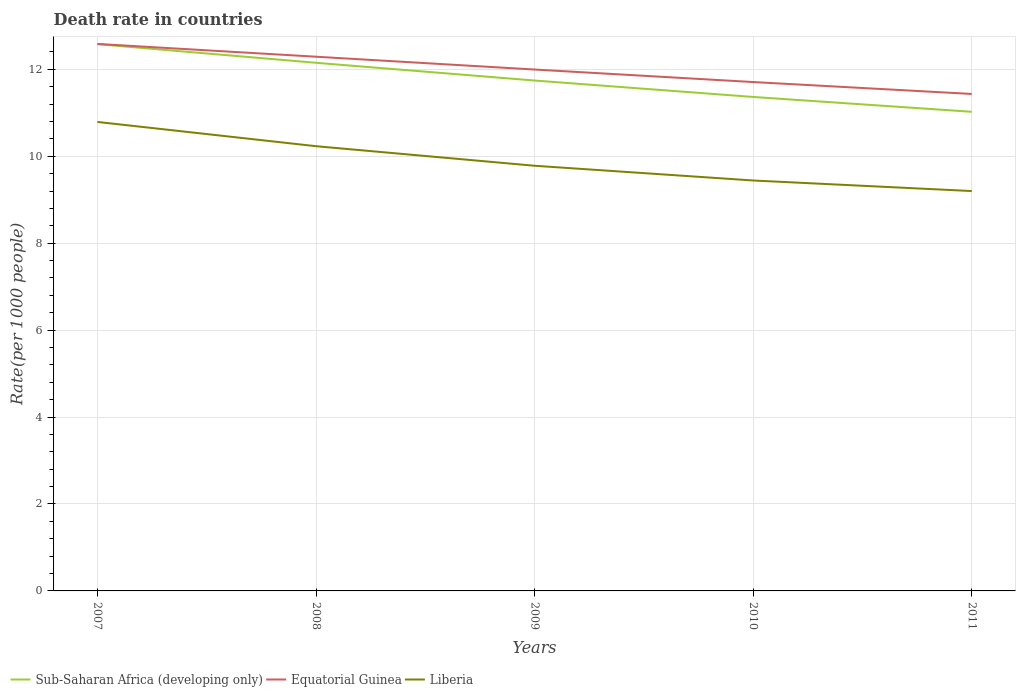Does the line corresponding to Equatorial Guinea intersect with the line corresponding to Liberia?
Ensure brevity in your answer.  No. Across all years, what is the maximum death rate in Sub-Saharan Africa (developing only)?
Your response must be concise. 11.02. What is the total death rate in Liberia in the graph?
Make the answer very short. 0.79. What is the difference between the highest and the second highest death rate in Equatorial Guinea?
Your response must be concise. 1.15. Is the death rate in Sub-Saharan Africa (developing only) strictly greater than the death rate in Equatorial Guinea over the years?
Provide a succinct answer. Yes. How many lines are there?
Provide a succinct answer. 3. How many years are there in the graph?
Ensure brevity in your answer.  5. Are the values on the major ticks of Y-axis written in scientific E-notation?
Offer a terse response. No. Does the graph contain any zero values?
Offer a terse response. No. Does the graph contain grids?
Keep it short and to the point. Yes. How many legend labels are there?
Ensure brevity in your answer.  3. How are the legend labels stacked?
Keep it short and to the point. Horizontal. What is the title of the graph?
Keep it short and to the point. Death rate in countries. What is the label or title of the X-axis?
Provide a short and direct response. Years. What is the label or title of the Y-axis?
Give a very brief answer. Rate(per 1000 people). What is the Rate(per 1000 people) in Sub-Saharan Africa (developing only) in 2007?
Your response must be concise. 12.58. What is the Rate(per 1000 people) of Equatorial Guinea in 2007?
Keep it short and to the point. 12.59. What is the Rate(per 1000 people) of Liberia in 2007?
Provide a succinct answer. 10.79. What is the Rate(per 1000 people) in Sub-Saharan Africa (developing only) in 2008?
Make the answer very short. 12.15. What is the Rate(per 1000 people) in Equatorial Guinea in 2008?
Your answer should be compact. 12.29. What is the Rate(per 1000 people) of Liberia in 2008?
Offer a terse response. 10.23. What is the Rate(per 1000 people) in Sub-Saharan Africa (developing only) in 2009?
Keep it short and to the point. 11.74. What is the Rate(per 1000 people) in Equatorial Guinea in 2009?
Your response must be concise. 12. What is the Rate(per 1000 people) of Liberia in 2009?
Offer a very short reply. 9.78. What is the Rate(per 1000 people) in Sub-Saharan Africa (developing only) in 2010?
Offer a very short reply. 11.36. What is the Rate(per 1000 people) in Equatorial Guinea in 2010?
Your answer should be compact. 11.71. What is the Rate(per 1000 people) in Liberia in 2010?
Give a very brief answer. 9.44. What is the Rate(per 1000 people) of Sub-Saharan Africa (developing only) in 2011?
Keep it short and to the point. 11.02. What is the Rate(per 1000 people) of Equatorial Guinea in 2011?
Offer a terse response. 11.43. Across all years, what is the maximum Rate(per 1000 people) in Sub-Saharan Africa (developing only)?
Keep it short and to the point. 12.58. Across all years, what is the maximum Rate(per 1000 people) in Equatorial Guinea?
Your answer should be compact. 12.59. Across all years, what is the maximum Rate(per 1000 people) in Liberia?
Provide a succinct answer. 10.79. Across all years, what is the minimum Rate(per 1000 people) of Sub-Saharan Africa (developing only)?
Your response must be concise. 11.02. Across all years, what is the minimum Rate(per 1000 people) of Equatorial Guinea?
Your answer should be compact. 11.43. What is the total Rate(per 1000 people) in Sub-Saharan Africa (developing only) in the graph?
Make the answer very short. 58.86. What is the total Rate(per 1000 people) of Equatorial Guinea in the graph?
Give a very brief answer. 60.01. What is the total Rate(per 1000 people) of Liberia in the graph?
Ensure brevity in your answer.  49.45. What is the difference between the Rate(per 1000 people) of Sub-Saharan Africa (developing only) in 2007 and that in 2008?
Ensure brevity in your answer.  0.43. What is the difference between the Rate(per 1000 people) of Equatorial Guinea in 2007 and that in 2008?
Your response must be concise. 0.29. What is the difference between the Rate(per 1000 people) of Liberia in 2007 and that in 2008?
Give a very brief answer. 0.56. What is the difference between the Rate(per 1000 people) in Sub-Saharan Africa (developing only) in 2007 and that in 2009?
Keep it short and to the point. 0.84. What is the difference between the Rate(per 1000 people) in Equatorial Guinea in 2007 and that in 2009?
Ensure brevity in your answer.  0.59. What is the difference between the Rate(per 1000 people) in Liberia in 2007 and that in 2009?
Your answer should be compact. 1.01. What is the difference between the Rate(per 1000 people) in Sub-Saharan Africa (developing only) in 2007 and that in 2010?
Your answer should be very brief. 1.21. What is the difference between the Rate(per 1000 people) in Equatorial Guinea in 2007 and that in 2010?
Make the answer very short. 0.88. What is the difference between the Rate(per 1000 people) in Liberia in 2007 and that in 2010?
Give a very brief answer. 1.35. What is the difference between the Rate(per 1000 people) in Sub-Saharan Africa (developing only) in 2007 and that in 2011?
Keep it short and to the point. 1.56. What is the difference between the Rate(per 1000 people) of Equatorial Guinea in 2007 and that in 2011?
Give a very brief answer. 1.15. What is the difference between the Rate(per 1000 people) in Liberia in 2007 and that in 2011?
Provide a short and direct response. 1.59. What is the difference between the Rate(per 1000 people) in Sub-Saharan Africa (developing only) in 2008 and that in 2009?
Your answer should be compact. 0.41. What is the difference between the Rate(per 1000 people) of Equatorial Guinea in 2008 and that in 2009?
Your answer should be compact. 0.29. What is the difference between the Rate(per 1000 people) in Liberia in 2008 and that in 2009?
Your answer should be very brief. 0.45. What is the difference between the Rate(per 1000 people) of Sub-Saharan Africa (developing only) in 2008 and that in 2010?
Provide a succinct answer. 0.79. What is the difference between the Rate(per 1000 people) in Equatorial Guinea in 2008 and that in 2010?
Your response must be concise. 0.58. What is the difference between the Rate(per 1000 people) in Liberia in 2008 and that in 2010?
Provide a succinct answer. 0.79. What is the difference between the Rate(per 1000 people) of Sub-Saharan Africa (developing only) in 2008 and that in 2011?
Provide a succinct answer. 1.13. What is the difference between the Rate(per 1000 people) in Equatorial Guinea in 2008 and that in 2011?
Ensure brevity in your answer.  0.86. What is the difference between the Rate(per 1000 people) of Liberia in 2008 and that in 2011?
Your response must be concise. 1.03. What is the difference between the Rate(per 1000 people) in Sub-Saharan Africa (developing only) in 2009 and that in 2010?
Provide a short and direct response. 0.38. What is the difference between the Rate(per 1000 people) in Equatorial Guinea in 2009 and that in 2010?
Offer a terse response. 0.29. What is the difference between the Rate(per 1000 people) of Liberia in 2009 and that in 2010?
Your answer should be very brief. 0.34. What is the difference between the Rate(per 1000 people) of Sub-Saharan Africa (developing only) in 2009 and that in 2011?
Offer a very short reply. 0.72. What is the difference between the Rate(per 1000 people) of Equatorial Guinea in 2009 and that in 2011?
Provide a succinct answer. 0.56. What is the difference between the Rate(per 1000 people) in Liberia in 2009 and that in 2011?
Make the answer very short. 0.58. What is the difference between the Rate(per 1000 people) of Sub-Saharan Africa (developing only) in 2010 and that in 2011?
Offer a very short reply. 0.34. What is the difference between the Rate(per 1000 people) of Equatorial Guinea in 2010 and that in 2011?
Provide a short and direct response. 0.27. What is the difference between the Rate(per 1000 people) of Liberia in 2010 and that in 2011?
Your answer should be compact. 0.24. What is the difference between the Rate(per 1000 people) in Sub-Saharan Africa (developing only) in 2007 and the Rate(per 1000 people) in Equatorial Guinea in 2008?
Offer a very short reply. 0.29. What is the difference between the Rate(per 1000 people) in Sub-Saharan Africa (developing only) in 2007 and the Rate(per 1000 people) in Liberia in 2008?
Offer a terse response. 2.35. What is the difference between the Rate(per 1000 people) of Equatorial Guinea in 2007 and the Rate(per 1000 people) of Liberia in 2008?
Provide a succinct answer. 2.35. What is the difference between the Rate(per 1000 people) in Sub-Saharan Africa (developing only) in 2007 and the Rate(per 1000 people) in Equatorial Guinea in 2009?
Offer a very short reply. 0.58. What is the difference between the Rate(per 1000 people) in Sub-Saharan Africa (developing only) in 2007 and the Rate(per 1000 people) in Liberia in 2009?
Your answer should be very brief. 2.8. What is the difference between the Rate(per 1000 people) of Equatorial Guinea in 2007 and the Rate(per 1000 people) of Liberia in 2009?
Keep it short and to the point. 2.8. What is the difference between the Rate(per 1000 people) in Sub-Saharan Africa (developing only) in 2007 and the Rate(per 1000 people) in Equatorial Guinea in 2010?
Make the answer very short. 0.87. What is the difference between the Rate(per 1000 people) in Sub-Saharan Africa (developing only) in 2007 and the Rate(per 1000 people) in Liberia in 2010?
Ensure brevity in your answer.  3.14. What is the difference between the Rate(per 1000 people) of Equatorial Guinea in 2007 and the Rate(per 1000 people) of Liberia in 2010?
Offer a very short reply. 3.14. What is the difference between the Rate(per 1000 people) of Sub-Saharan Africa (developing only) in 2007 and the Rate(per 1000 people) of Equatorial Guinea in 2011?
Your response must be concise. 1.15. What is the difference between the Rate(per 1000 people) in Sub-Saharan Africa (developing only) in 2007 and the Rate(per 1000 people) in Liberia in 2011?
Provide a succinct answer. 3.38. What is the difference between the Rate(per 1000 people) in Equatorial Guinea in 2007 and the Rate(per 1000 people) in Liberia in 2011?
Your answer should be compact. 3.38. What is the difference between the Rate(per 1000 people) in Sub-Saharan Africa (developing only) in 2008 and the Rate(per 1000 people) in Equatorial Guinea in 2009?
Provide a short and direct response. 0.16. What is the difference between the Rate(per 1000 people) of Sub-Saharan Africa (developing only) in 2008 and the Rate(per 1000 people) of Liberia in 2009?
Your answer should be very brief. 2.37. What is the difference between the Rate(per 1000 people) in Equatorial Guinea in 2008 and the Rate(per 1000 people) in Liberia in 2009?
Provide a succinct answer. 2.51. What is the difference between the Rate(per 1000 people) of Sub-Saharan Africa (developing only) in 2008 and the Rate(per 1000 people) of Equatorial Guinea in 2010?
Provide a succinct answer. 0.44. What is the difference between the Rate(per 1000 people) of Sub-Saharan Africa (developing only) in 2008 and the Rate(per 1000 people) of Liberia in 2010?
Your answer should be very brief. 2.71. What is the difference between the Rate(per 1000 people) of Equatorial Guinea in 2008 and the Rate(per 1000 people) of Liberia in 2010?
Your answer should be very brief. 2.85. What is the difference between the Rate(per 1000 people) of Sub-Saharan Africa (developing only) in 2008 and the Rate(per 1000 people) of Equatorial Guinea in 2011?
Ensure brevity in your answer.  0.72. What is the difference between the Rate(per 1000 people) in Sub-Saharan Africa (developing only) in 2008 and the Rate(per 1000 people) in Liberia in 2011?
Provide a short and direct response. 2.95. What is the difference between the Rate(per 1000 people) in Equatorial Guinea in 2008 and the Rate(per 1000 people) in Liberia in 2011?
Provide a short and direct response. 3.09. What is the difference between the Rate(per 1000 people) of Sub-Saharan Africa (developing only) in 2009 and the Rate(per 1000 people) of Equatorial Guinea in 2010?
Your response must be concise. 0.03. What is the difference between the Rate(per 1000 people) in Sub-Saharan Africa (developing only) in 2009 and the Rate(per 1000 people) in Liberia in 2010?
Provide a succinct answer. 2.3. What is the difference between the Rate(per 1000 people) of Equatorial Guinea in 2009 and the Rate(per 1000 people) of Liberia in 2010?
Offer a very short reply. 2.55. What is the difference between the Rate(per 1000 people) in Sub-Saharan Africa (developing only) in 2009 and the Rate(per 1000 people) in Equatorial Guinea in 2011?
Your response must be concise. 0.31. What is the difference between the Rate(per 1000 people) in Sub-Saharan Africa (developing only) in 2009 and the Rate(per 1000 people) in Liberia in 2011?
Your response must be concise. 2.54. What is the difference between the Rate(per 1000 people) of Equatorial Guinea in 2009 and the Rate(per 1000 people) of Liberia in 2011?
Offer a very short reply. 2.8. What is the difference between the Rate(per 1000 people) of Sub-Saharan Africa (developing only) in 2010 and the Rate(per 1000 people) of Equatorial Guinea in 2011?
Provide a short and direct response. -0.07. What is the difference between the Rate(per 1000 people) of Sub-Saharan Africa (developing only) in 2010 and the Rate(per 1000 people) of Liberia in 2011?
Ensure brevity in your answer.  2.17. What is the difference between the Rate(per 1000 people) in Equatorial Guinea in 2010 and the Rate(per 1000 people) in Liberia in 2011?
Your response must be concise. 2.51. What is the average Rate(per 1000 people) in Sub-Saharan Africa (developing only) per year?
Your response must be concise. 11.77. What is the average Rate(per 1000 people) in Equatorial Guinea per year?
Your answer should be compact. 12. What is the average Rate(per 1000 people) of Liberia per year?
Your answer should be very brief. 9.89. In the year 2007, what is the difference between the Rate(per 1000 people) in Sub-Saharan Africa (developing only) and Rate(per 1000 people) in Equatorial Guinea?
Provide a short and direct response. -0.01. In the year 2007, what is the difference between the Rate(per 1000 people) of Sub-Saharan Africa (developing only) and Rate(per 1000 people) of Liberia?
Provide a short and direct response. 1.79. In the year 2007, what is the difference between the Rate(per 1000 people) in Equatorial Guinea and Rate(per 1000 people) in Liberia?
Make the answer very short. 1.79. In the year 2008, what is the difference between the Rate(per 1000 people) in Sub-Saharan Africa (developing only) and Rate(per 1000 people) in Equatorial Guinea?
Keep it short and to the point. -0.14. In the year 2008, what is the difference between the Rate(per 1000 people) in Sub-Saharan Africa (developing only) and Rate(per 1000 people) in Liberia?
Provide a succinct answer. 1.92. In the year 2008, what is the difference between the Rate(per 1000 people) in Equatorial Guinea and Rate(per 1000 people) in Liberia?
Provide a short and direct response. 2.06. In the year 2009, what is the difference between the Rate(per 1000 people) in Sub-Saharan Africa (developing only) and Rate(per 1000 people) in Equatorial Guinea?
Give a very brief answer. -0.25. In the year 2009, what is the difference between the Rate(per 1000 people) in Sub-Saharan Africa (developing only) and Rate(per 1000 people) in Liberia?
Your answer should be compact. 1.96. In the year 2009, what is the difference between the Rate(per 1000 people) in Equatorial Guinea and Rate(per 1000 people) in Liberia?
Give a very brief answer. 2.21. In the year 2010, what is the difference between the Rate(per 1000 people) in Sub-Saharan Africa (developing only) and Rate(per 1000 people) in Equatorial Guinea?
Keep it short and to the point. -0.34. In the year 2010, what is the difference between the Rate(per 1000 people) of Sub-Saharan Africa (developing only) and Rate(per 1000 people) of Liberia?
Keep it short and to the point. 1.92. In the year 2010, what is the difference between the Rate(per 1000 people) in Equatorial Guinea and Rate(per 1000 people) in Liberia?
Keep it short and to the point. 2.27. In the year 2011, what is the difference between the Rate(per 1000 people) of Sub-Saharan Africa (developing only) and Rate(per 1000 people) of Equatorial Guinea?
Keep it short and to the point. -0.41. In the year 2011, what is the difference between the Rate(per 1000 people) of Sub-Saharan Africa (developing only) and Rate(per 1000 people) of Liberia?
Ensure brevity in your answer.  1.82. In the year 2011, what is the difference between the Rate(per 1000 people) in Equatorial Guinea and Rate(per 1000 people) in Liberia?
Ensure brevity in your answer.  2.23. What is the ratio of the Rate(per 1000 people) of Sub-Saharan Africa (developing only) in 2007 to that in 2008?
Your answer should be compact. 1.04. What is the ratio of the Rate(per 1000 people) in Equatorial Guinea in 2007 to that in 2008?
Keep it short and to the point. 1.02. What is the ratio of the Rate(per 1000 people) in Liberia in 2007 to that in 2008?
Your answer should be very brief. 1.05. What is the ratio of the Rate(per 1000 people) of Sub-Saharan Africa (developing only) in 2007 to that in 2009?
Ensure brevity in your answer.  1.07. What is the ratio of the Rate(per 1000 people) in Equatorial Guinea in 2007 to that in 2009?
Provide a succinct answer. 1.05. What is the ratio of the Rate(per 1000 people) of Liberia in 2007 to that in 2009?
Offer a very short reply. 1.1. What is the ratio of the Rate(per 1000 people) of Sub-Saharan Africa (developing only) in 2007 to that in 2010?
Provide a succinct answer. 1.11. What is the ratio of the Rate(per 1000 people) in Equatorial Guinea in 2007 to that in 2010?
Give a very brief answer. 1.07. What is the ratio of the Rate(per 1000 people) of Liberia in 2007 to that in 2010?
Your answer should be compact. 1.14. What is the ratio of the Rate(per 1000 people) in Sub-Saharan Africa (developing only) in 2007 to that in 2011?
Your answer should be compact. 1.14. What is the ratio of the Rate(per 1000 people) in Equatorial Guinea in 2007 to that in 2011?
Give a very brief answer. 1.1. What is the ratio of the Rate(per 1000 people) in Liberia in 2007 to that in 2011?
Provide a short and direct response. 1.17. What is the ratio of the Rate(per 1000 people) of Sub-Saharan Africa (developing only) in 2008 to that in 2009?
Provide a short and direct response. 1.03. What is the ratio of the Rate(per 1000 people) of Equatorial Guinea in 2008 to that in 2009?
Give a very brief answer. 1.02. What is the ratio of the Rate(per 1000 people) in Liberia in 2008 to that in 2009?
Your response must be concise. 1.05. What is the ratio of the Rate(per 1000 people) of Sub-Saharan Africa (developing only) in 2008 to that in 2010?
Your answer should be compact. 1.07. What is the ratio of the Rate(per 1000 people) of Equatorial Guinea in 2008 to that in 2010?
Offer a terse response. 1.05. What is the ratio of the Rate(per 1000 people) in Liberia in 2008 to that in 2010?
Provide a short and direct response. 1.08. What is the ratio of the Rate(per 1000 people) in Sub-Saharan Africa (developing only) in 2008 to that in 2011?
Provide a short and direct response. 1.1. What is the ratio of the Rate(per 1000 people) of Equatorial Guinea in 2008 to that in 2011?
Your answer should be very brief. 1.07. What is the ratio of the Rate(per 1000 people) of Liberia in 2008 to that in 2011?
Provide a short and direct response. 1.11. What is the ratio of the Rate(per 1000 people) in Sub-Saharan Africa (developing only) in 2009 to that in 2010?
Offer a very short reply. 1.03. What is the ratio of the Rate(per 1000 people) in Equatorial Guinea in 2009 to that in 2010?
Your response must be concise. 1.02. What is the ratio of the Rate(per 1000 people) of Liberia in 2009 to that in 2010?
Keep it short and to the point. 1.04. What is the ratio of the Rate(per 1000 people) in Sub-Saharan Africa (developing only) in 2009 to that in 2011?
Your answer should be compact. 1.07. What is the ratio of the Rate(per 1000 people) of Equatorial Guinea in 2009 to that in 2011?
Provide a succinct answer. 1.05. What is the ratio of the Rate(per 1000 people) of Liberia in 2009 to that in 2011?
Keep it short and to the point. 1.06. What is the ratio of the Rate(per 1000 people) of Sub-Saharan Africa (developing only) in 2010 to that in 2011?
Ensure brevity in your answer.  1.03. What is the ratio of the Rate(per 1000 people) in Equatorial Guinea in 2010 to that in 2011?
Your answer should be compact. 1.02. What is the ratio of the Rate(per 1000 people) of Liberia in 2010 to that in 2011?
Give a very brief answer. 1.03. What is the difference between the highest and the second highest Rate(per 1000 people) in Sub-Saharan Africa (developing only)?
Give a very brief answer. 0.43. What is the difference between the highest and the second highest Rate(per 1000 people) of Equatorial Guinea?
Ensure brevity in your answer.  0.29. What is the difference between the highest and the second highest Rate(per 1000 people) in Liberia?
Give a very brief answer. 0.56. What is the difference between the highest and the lowest Rate(per 1000 people) of Sub-Saharan Africa (developing only)?
Provide a short and direct response. 1.56. What is the difference between the highest and the lowest Rate(per 1000 people) of Equatorial Guinea?
Your answer should be very brief. 1.15. What is the difference between the highest and the lowest Rate(per 1000 people) of Liberia?
Make the answer very short. 1.59. 